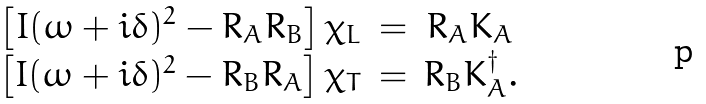Convert formula to latex. <formula><loc_0><loc_0><loc_500><loc_500>\begin{array} { c c c } \left [ I ( \omega + i \delta ) ^ { 2 } - R _ { A } R _ { B } \right ] \chi _ { L } & = & R _ { A } K _ { A } \\ \left [ I ( \omega + i \delta ) ^ { 2 } - R _ { B } R _ { A } \right ] \chi _ { T } & = & R _ { B } K _ { A } ^ { \dagger } . \end{array}</formula> 